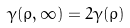<formula> <loc_0><loc_0><loc_500><loc_500>\gamma ( \rho , \infty ) = 2 \gamma ( \rho )</formula> 